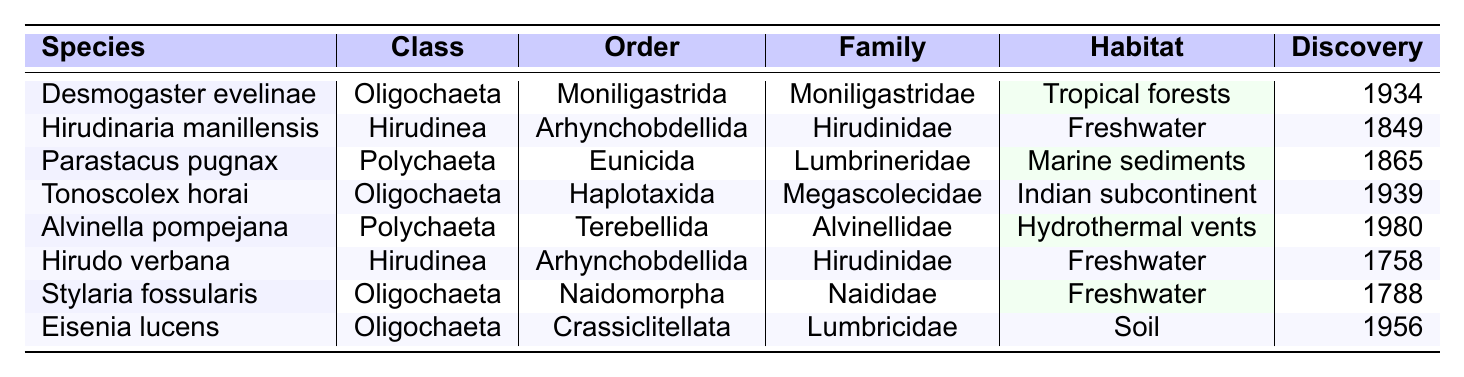What is the habitat of Desmogaster evelinae? The table lists the habitat for Desmogaster evelinae as "Tropical forests."
Answer: Tropical forests Which species was discovered the earliest? By checking the discovery years, Hirudo verbana has the year 1758, which is earlier than all other species in the table.
Answer: Hirudo verbana How many species belong to the class Oligochaeta? The table shows three entries under the class Oligochaeta: Desmogaster evelinae, Tonoscolex horai, and Stylaria fossularis, resulting in a total of three species.
Answer: 3 Is Tonoscolex horai found in freshwater? The habitat for Tonoscolex horai is listed as "Indian subcontinent," which does not specify freshwater, indicating it is not found in freshwater.
Answer: No What is the average discovery year for Polychaeta species? The Polychaeta species are Parastacus pugnax (1865) and Alvinella pompejana (1980). Their average is (1865 + 1980) / 2 = 1922.5.
Answer: 1922.5 Which family does Hirudinaria manillensis belong to? The table indicates that Hirudinaria manillensis is part of the family Hirudinidae.
Answer: Hirudinidae Are there any annelid species discovered after 1950? The species discovered after 1950 are Alvinella pompejana (1980) and Eisenia lucens (1956), confirming that there are species discovered after 1950.
Answer: Yes Count the total number of annelid species listed in the table. There are a total of 8 species listed in the table when counted.
Answer: 8 Which class has the highest representation among the rare species listed? The class Oligochaeta has 4 entries (Desmogaster evelinae, Tonoscolex horai, Stylaria fossularis, and Eisenia lucens), making it the most represented class.
Answer: Oligochaeta What order does Alvinella pompejana belong to? The table reveals that Alvinella pompejana belongs to the order Terebellida.
Answer: Terebellida Determine if all species in the table were discovered in the 20th century. The species Hirudo verbana (1758) and Hirudinaria manillensis (1849) were discovered in the 18th and 19th centuries, respectively, showing not all species were discovered in the 20th century.
Answer: No 